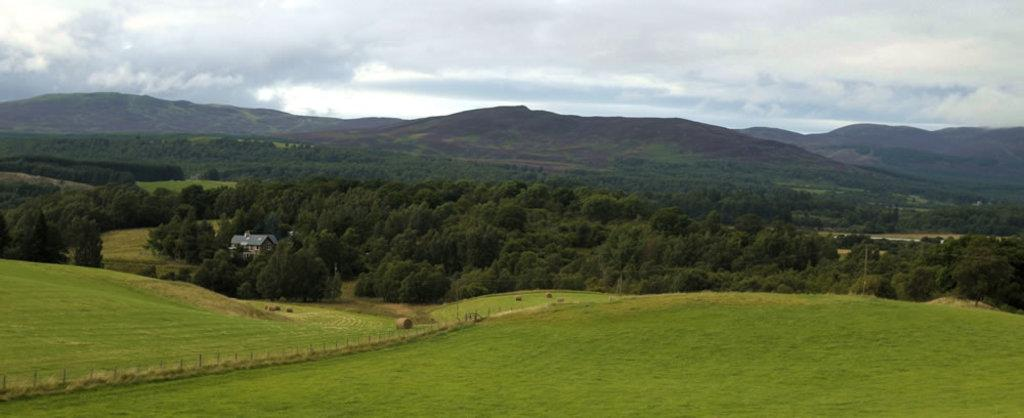What type of vegetation is present in the image? There is green grass in the image. What other natural elements can be seen in the image? There are trees in the image. What type of structure is visible in the image? There is a house in the image. What can be seen in the distance in the image? There are hills visible in the background of the image. What is visible above the hills in the image? The sky is visible in the background of the image, and clouds are present in the sky. How many sisters are sitting on the sofa in the image? There is no sofa or sisters present in the image. How can the grass be measured in the image? The grass cannot be measured in the image; it is not possible to determine its exact dimensions from the picture. 